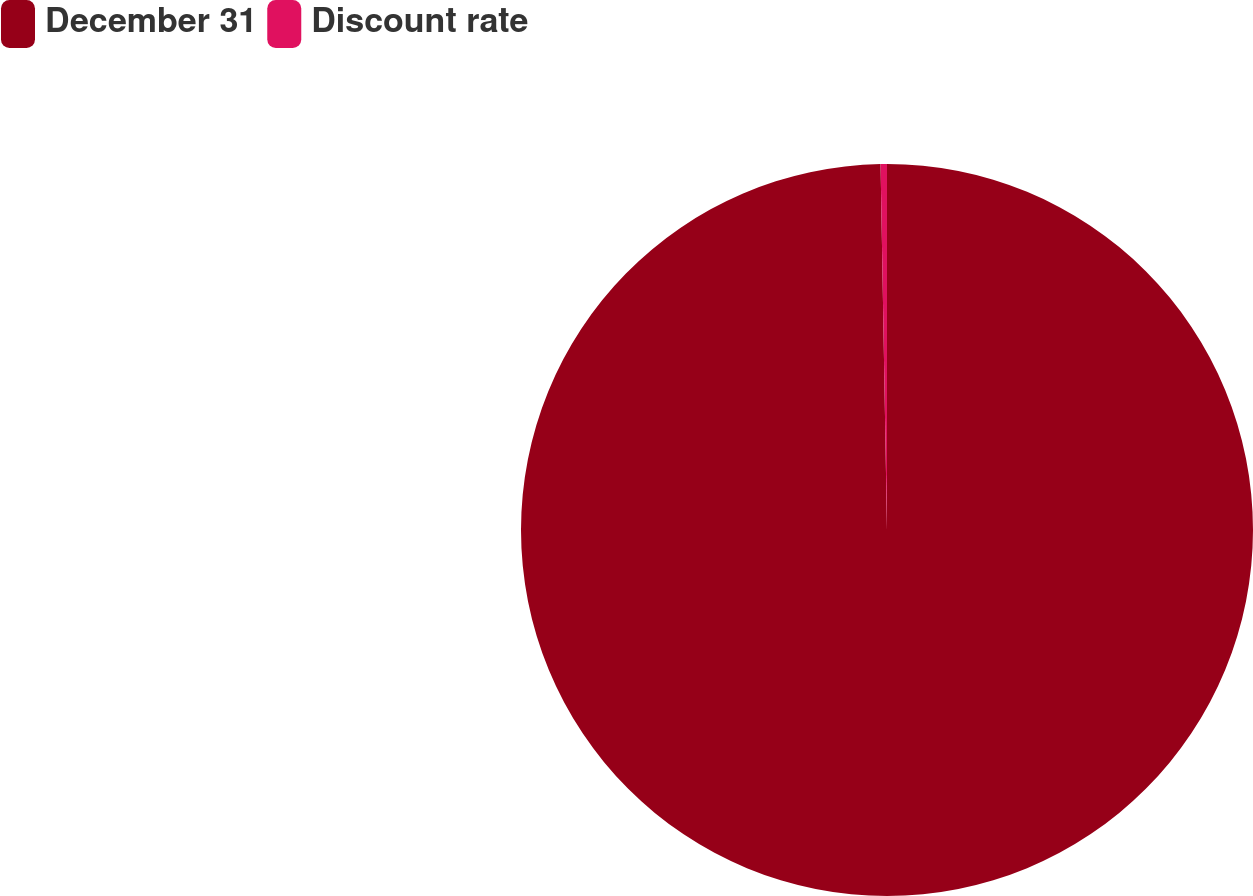Convert chart. <chart><loc_0><loc_0><loc_500><loc_500><pie_chart><fcel>December 31<fcel>Discount rate<nl><fcel>99.72%<fcel>0.28%<nl></chart> 